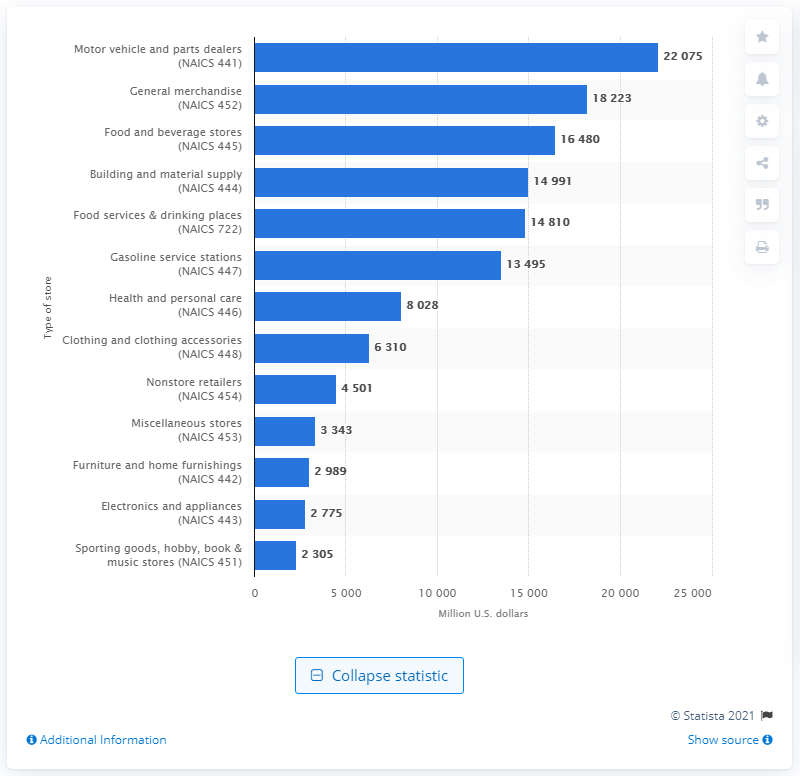Mention a couple of crucial points in this snapshot. In 2009, the total sales of food and beverage in the state of Georgia amounted to 16,480. 